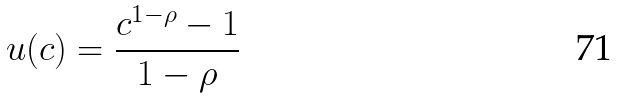<formula> <loc_0><loc_0><loc_500><loc_500>u ( c ) = \frac { c ^ { 1 - \rho } - 1 } { 1 - \rho }</formula> 